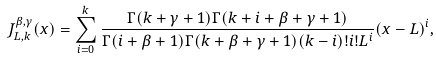<formula> <loc_0><loc_0><loc_500><loc_500>J _ { L , k } ^ { \beta , \gamma } ( x ) = \sum _ { i = 0 } ^ { k } \frac { \Gamma ( k + \gamma + 1 ) \Gamma ( k + i + \beta + \gamma + 1 ) } { \Gamma ( i + \beta + 1 ) \Gamma ( k + \beta + \gamma + 1 ) ( k - i ) ! i ! L ^ { i } } ( x - L ) ^ { i } ,</formula> 